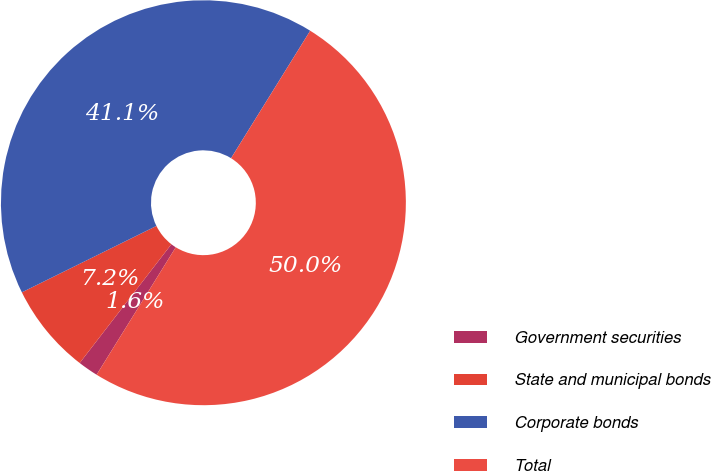<chart> <loc_0><loc_0><loc_500><loc_500><pie_chart><fcel>Government securities<fcel>State and municipal bonds<fcel>Corporate bonds<fcel>Total<nl><fcel>1.62%<fcel>7.24%<fcel>41.14%<fcel>50.0%<nl></chart> 